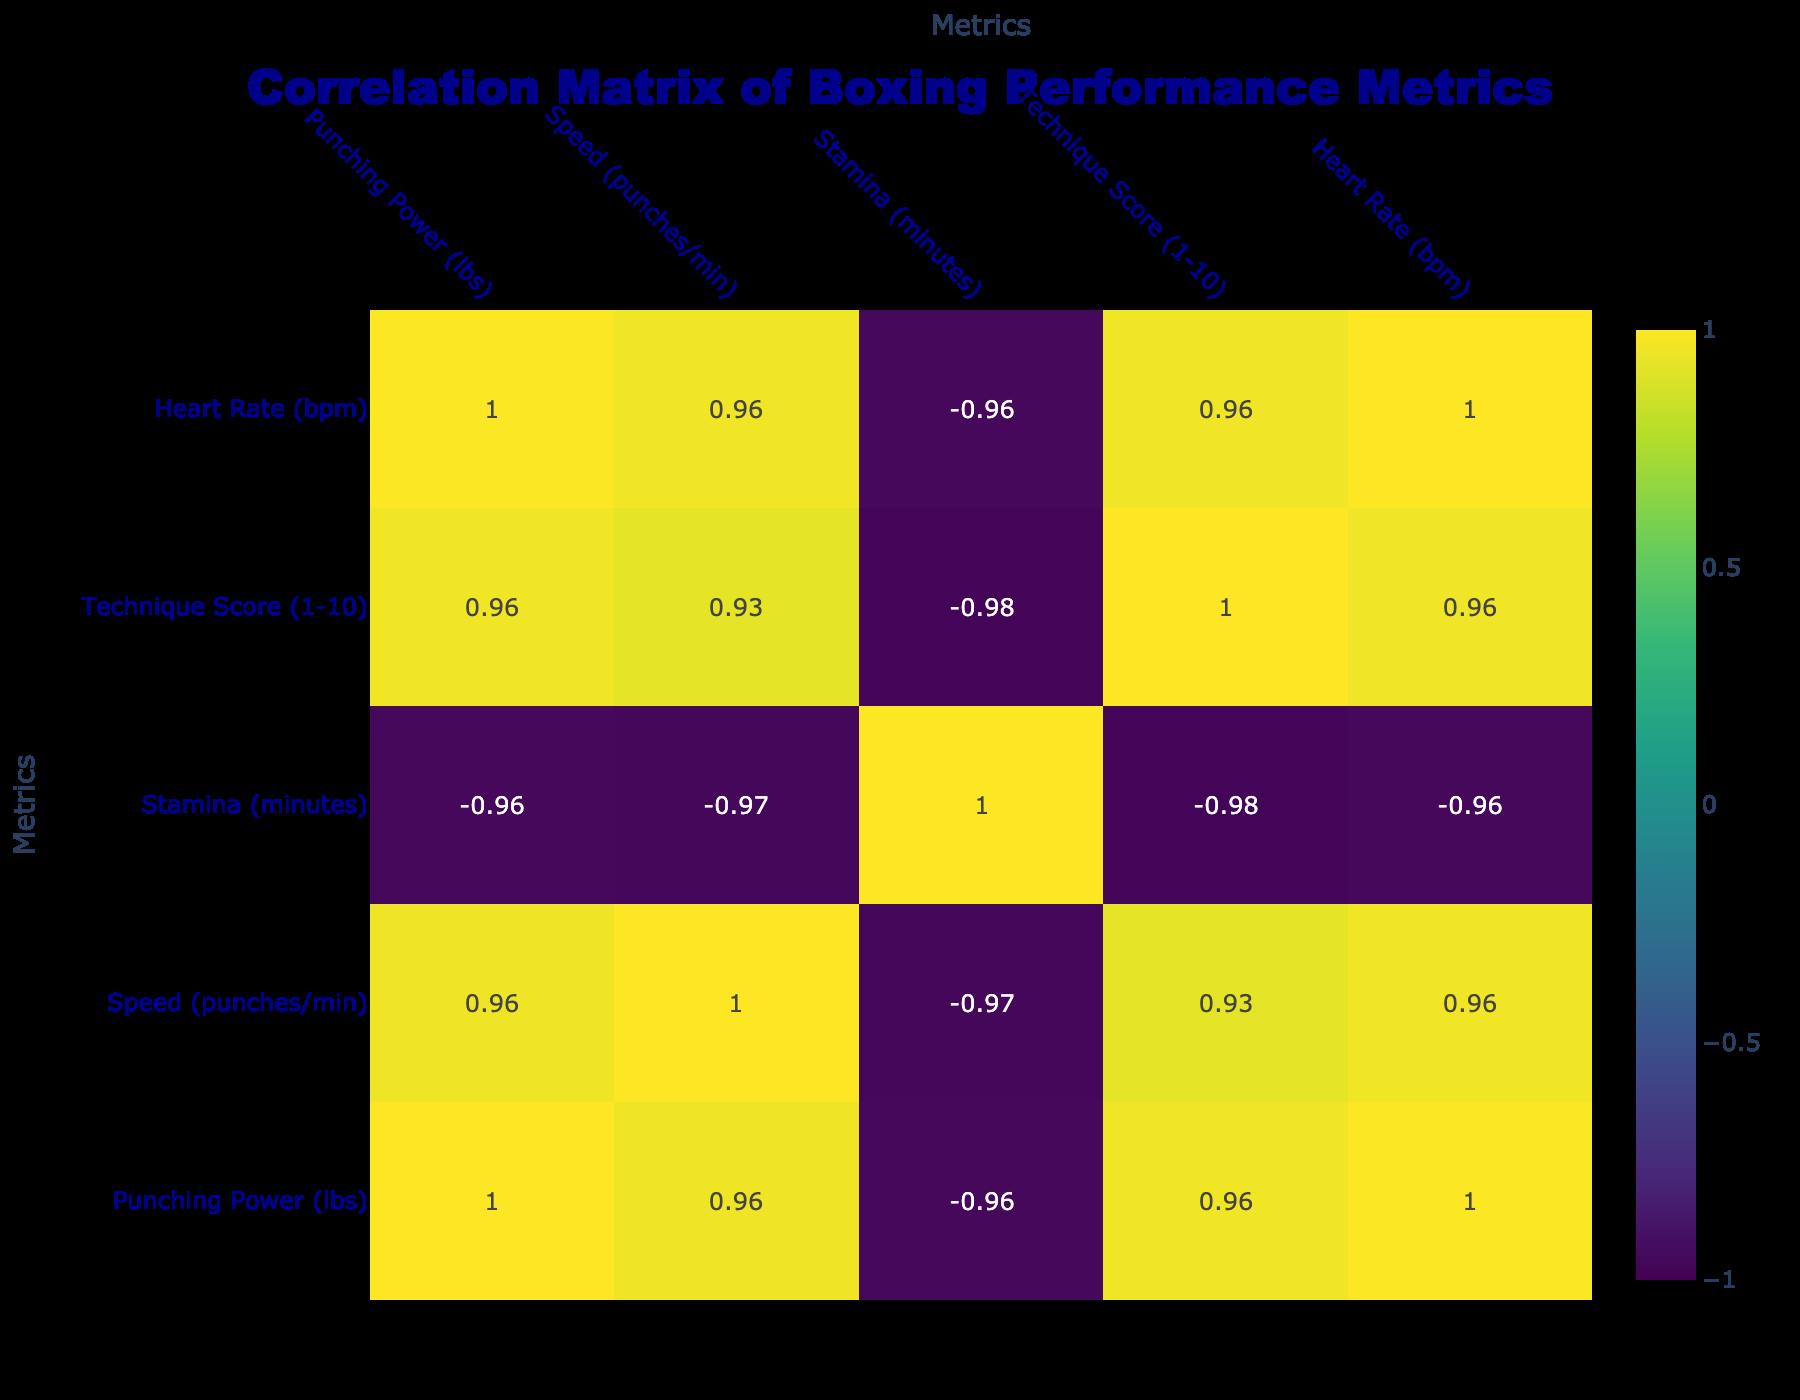What is the punching power at high training intensity? From the table, we can directly look at the row corresponding to high training intensity, which shows a punching power of 180 lbs.
Answer: 180 lbs What is the speed (punches/min) at low training intensity? Referring to the table, the row for low training intensity indicates a speed of 50 punches per minute.
Answer: 50 punches/min What is the average heart rate across all training intensities? To find the average heart rate, we sum the heart rates (110 + 130 + 150 + 115 + 135 + 160 + 120 + 145 + 155) which equals 1,215. There are 9 entries, so the average heart rate is 1,215 / 9 = 135.
Answer: 135 bpm Does a higher training intensity correspond to a higher stamina? Looking at the stamina values for the different training intensities: Low (30, 32, 28), Medium (25, 24, 22), High (20, 18, 15). As the training intensity increases, the stamina values decrease. Therefore, the statement is false.
Answer: No What is the difference in technique score between medium and high training intensities? The technique scores for medium and high training intensities are 7 and 9, respectively. The difference is 9 - 7 = 2.
Answer: 2 Is the relationship between punching power and heart rate positive or negative? Analyzing the correlation between punching power (120, 150, 180, 125, 160, 200, 130, 170, 190) and heart rate (110, 130, 150, 115, 135, 160, 120, 145, 155), we observe that as punching power increases, heart rate also increases, indicating a positive relationship.
Answer: Positive What is the maximum speed recorded in all sessions? The speed values are 50, 70, 90, 55, 75, 85, 60, 80, and 95. The maximum value is 95 punches per minute from the high training intensity session.
Answer: 95 punches/min Which training intensity has the lowest stamina, and what is its value? From the table, the low training intensity rows show staminas of 30, 32, and 28 minutes. The minimum value is 15 minutes for high training intensity, making high intensity have the lowest stamina.
Answer: High intensity, 15 minutes What is the heart rate at medium training intensity with the highest technique score? The highest technique score at medium training intensity is 8, which corresponds to a heart rate of 145 bpm.
Answer: 145 bpm 